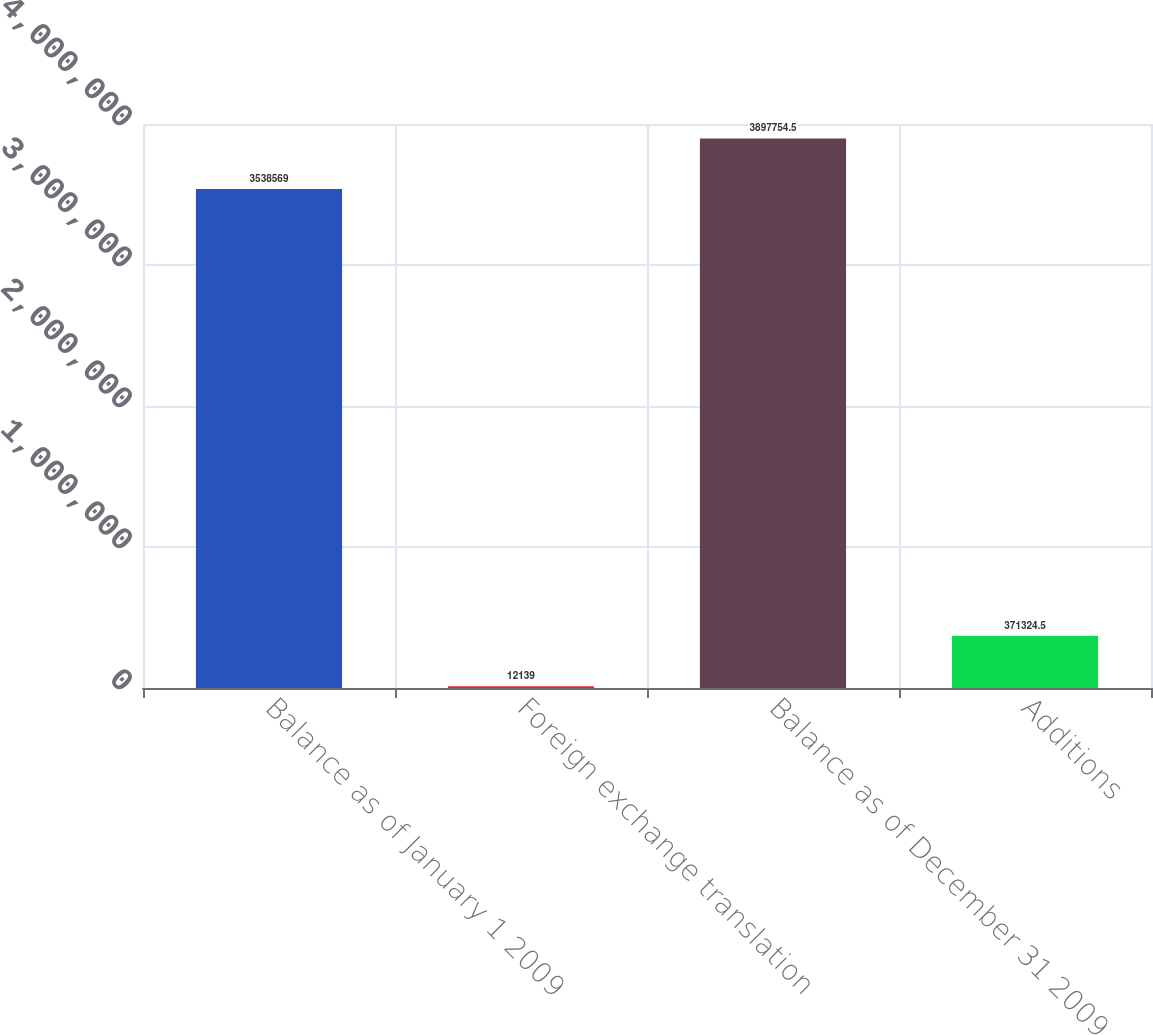Convert chart to OTSL. <chart><loc_0><loc_0><loc_500><loc_500><bar_chart><fcel>Balance as of January 1 2009<fcel>Foreign exchange translation<fcel>Balance as of December 31 2009<fcel>Additions<nl><fcel>3.53857e+06<fcel>12139<fcel>3.89775e+06<fcel>371324<nl></chart> 